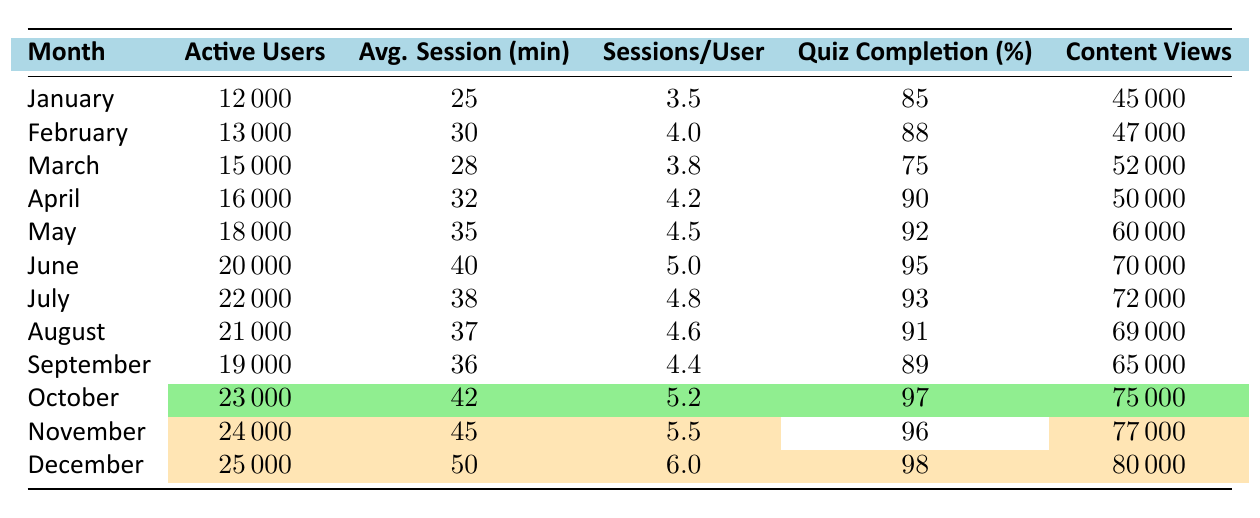What was the active user count in October? Referring to the table, the active user count for October is highlighted and shown as 23000.
Answer: 23000 What was the average session time in December? Looking at the table, the average session time in December is highlighted and is 50 minutes.
Answer: 50 What month had the highest quiz completion rate? By examining the quiz completion rates in the table, December has the highest rate at 98%.
Answer: December What is the difference in active users between June and May? From the table, June has 20000 active users and May has 18000. The difference is 20000 - 18000 = 2000.
Answer: 2000 What was the average quiz completion rate from June to December? The rates from June to December are 95, 93, 91, 89, 97, 96, and 98. Adding these gives 95 + 93 + 91 + 89 + 97 + 96 + 98 =  579. There are 7 months, so the average is 579 / 7 = 82.71 (rounded to two decimal points: 82.71).
Answer: 82.71 Did the number of active users increase every month in 2023? Checking the table monthly from January to December, every month shows an increase in active users. Therefore, the answer is yes.
Answer: Yes What is the total number of content views from January to March? The content views for January, February, and March are 45000, 47000, and 52000 respectively. The total is 45000 + 47000 + 52000 = 144000.
Answer: 144000 Which month had the highest sessions per user? In the table, November has the highest sessions per user at 5.5.
Answer: November What is the average number of active users between April and July? The active users for April, May, June, and July are 16000, 18000, 20000, and 22000. Their sum is 16000 + 18000 + 20000 + 22000 = 76000. There are 4 months, so the average is 76000 / 4 = 19000.
Answer: 19000 Was the average session time in July greater than or equal to that in May? The average session time in July is 38 minutes, and in May it is 35 minutes. Since 38 is greater than 35, the statement is true.
Answer: Yes 